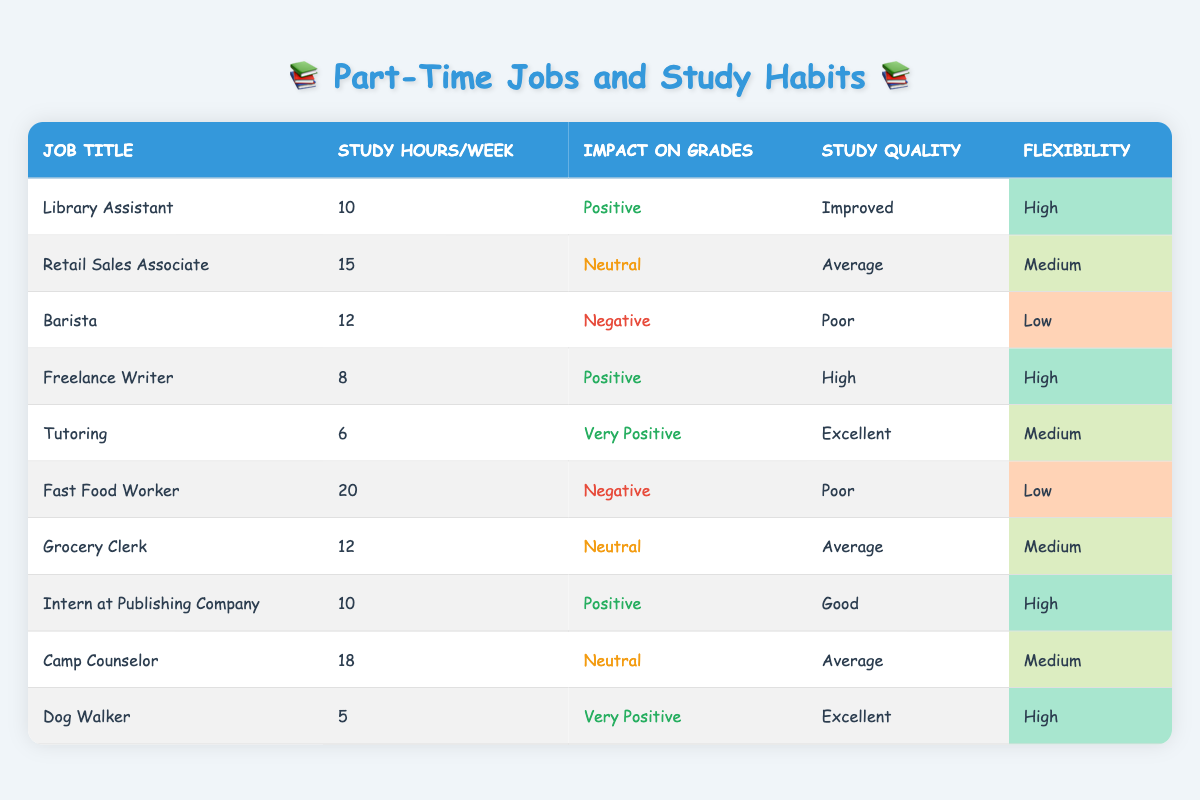What is the job that has the highest impact on grades? From the table, "Tutoring" has an impact on grades classified as "Very Positive," which is the highest rating present. Other jobs like "Dog Walker" also have a "Very Positive" impact but since the question is about the highest, we note both.
Answer: Tutoring and Dog Walker How many study hours per week does a Retail Sales Associate work? Looking at the row for "Retail Sales Associate," the study hours per week listed is 15.
Answer: 15 Which job offers the most flexibility? The jobs with "High" flexibility are "Library Assistant," "Freelance Writer," "Dog Walker," and "Intern at Publishing Company."
Answer: Library Assistant, Freelance Writer, Dog Walker, Intern at Publishing Company What is the average number of study hours per week for jobs with a negative impact on grades? To find the average, we look at the study hours for "Barista" (12 hours) and "Fast Food Worker" (20 hours). The average is calculated as follows: (12 + 20) / 2 = 16.
Answer: 16 Is the study quality for Fast Food Worker better than for Grocery Clerk? The study quality for "Fast Food Worker" is "Poor," while for "Grocery Clerk," it is "Average." Since "Average" is better than "Poor," the answer is true.
Answer: No Which job has the least number of study hours per week and what is its impact on grades? Looking at the table, "Dog Walker" has the least study hours per week at 5. Its impact on grades is "Very Positive."
Answer: Dog Walker, Very Positive Are there any jobs with a neutral impact on grades that also have high flexibility? Both "Retail Sales Associate" and "Grocery Clerk" have a neutral impact on grades but both have medium flexibility. Therefore, no jobs meet the criteria of having a neutral impact and high flexibility.
Answer: No How does the study quality of the Library Assistant compare to that of the Barista? The study quality for "Library Assistant" is "Improved," while for "Barista," it is "Poor," indicating that "Library Assistant" has a better study quality than "Barista."
Answer: Library Assistant is better 